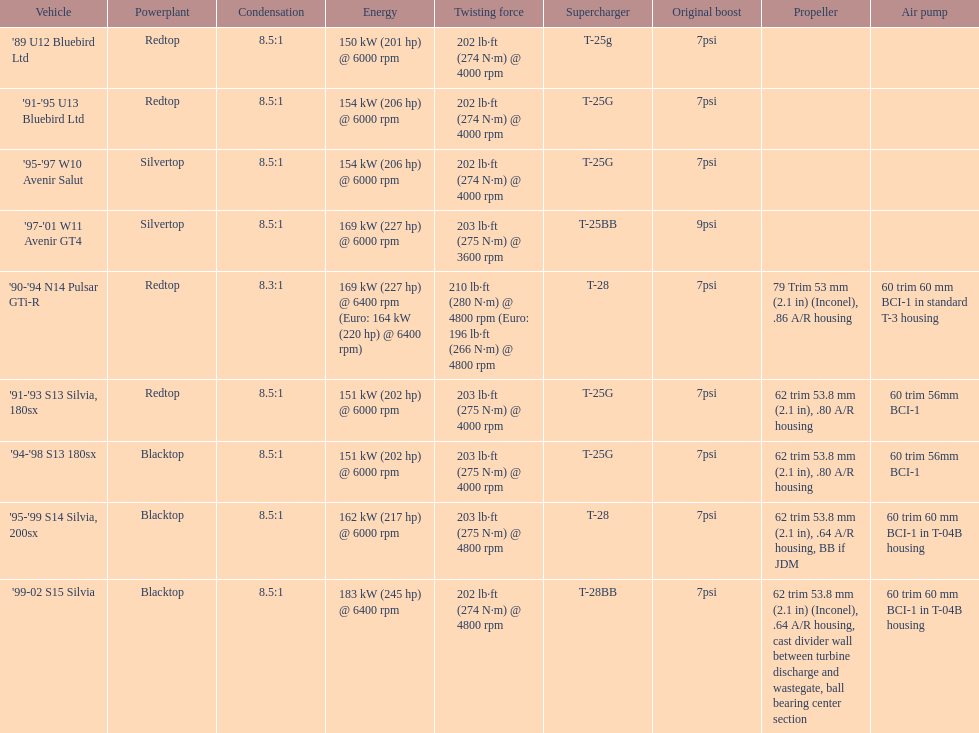Which engine has the smallest compression rate? '90-'94 N14 Pulsar GTi-R. 